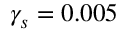<formula> <loc_0><loc_0><loc_500><loc_500>\gamma _ { s } = 0 . 0 0 5</formula> 